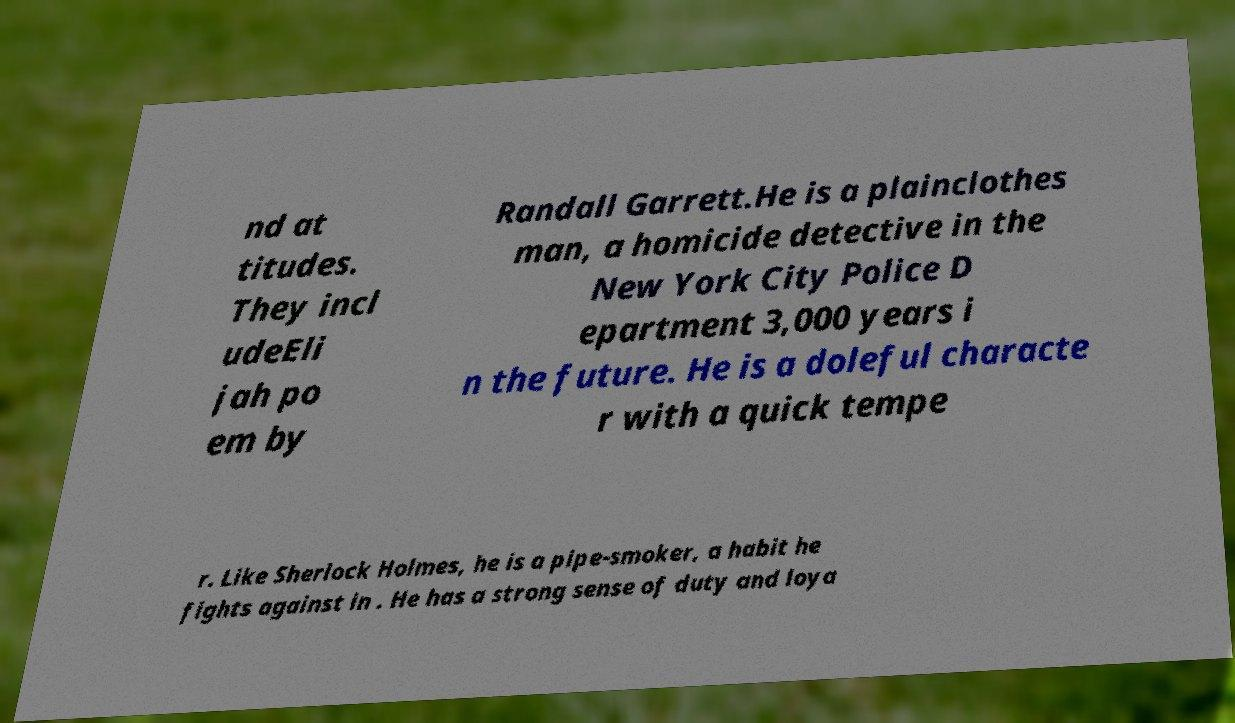Can you accurately transcribe the text from the provided image for me? nd at titudes. They incl udeEli jah po em by Randall Garrett.He is a plainclothes man, a homicide detective in the New York City Police D epartment 3,000 years i n the future. He is a doleful characte r with a quick tempe r. Like Sherlock Holmes, he is a pipe-smoker, a habit he fights against in . He has a strong sense of duty and loya 